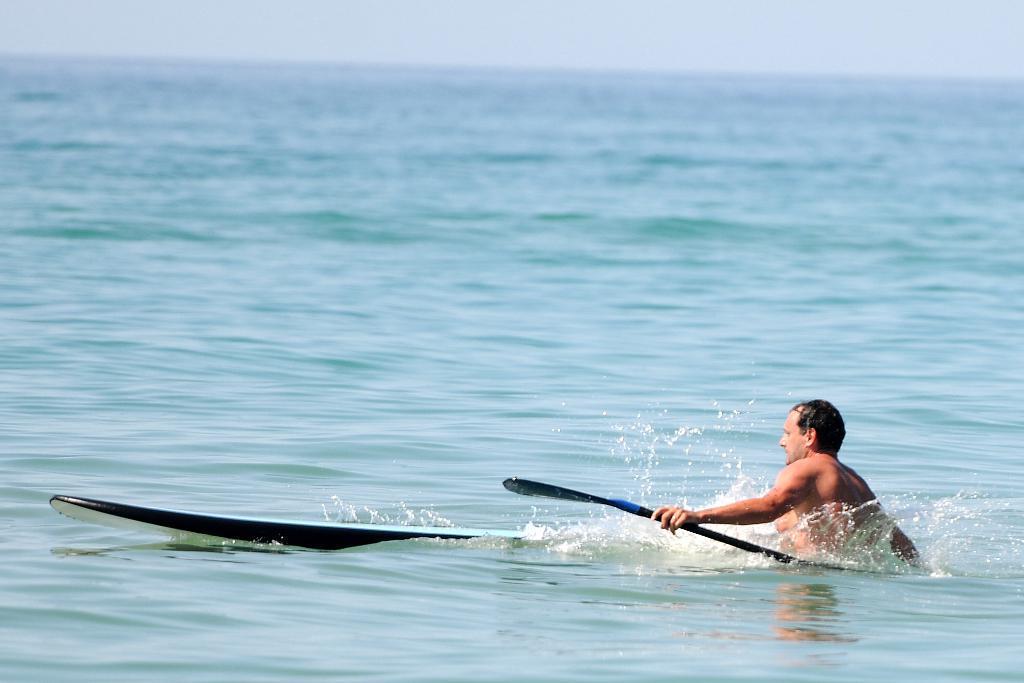In one or two sentences, can you explain what this image depicts? In this picture I can see a person holding a paddle in the water, there is a surfboard on the water, and in the background there is sky. 